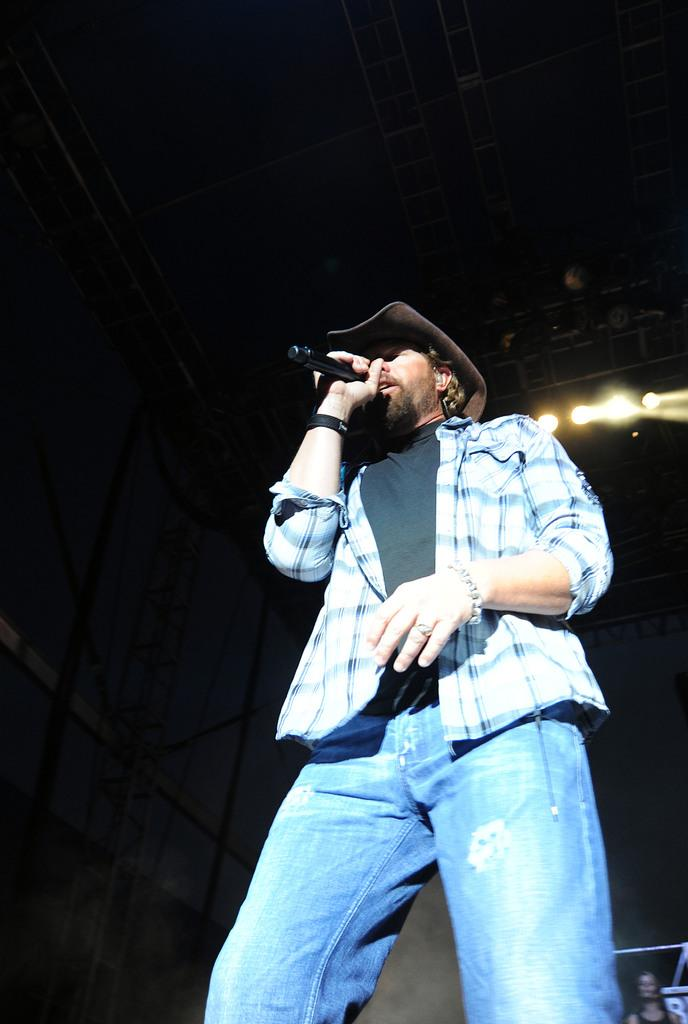Who is the main subject in the image? There is a man in the image. Where is the man located in the image? The man is standing on a stage. What is the man doing in the image? The man is singing a song. What is the man holding in his hand in the image? The man is holding a microphone in his hand. What accessory is the man wearing on his head in the image? The man is wearing a hat on his head. What type of plough is the man using to till the soil in the image? There is no plough present in the image; the man is singing on a stage. How does the ray of light affect the man's performance in the image? There is no mention of a ray of light in the image; the man is simply singing on a stage. 